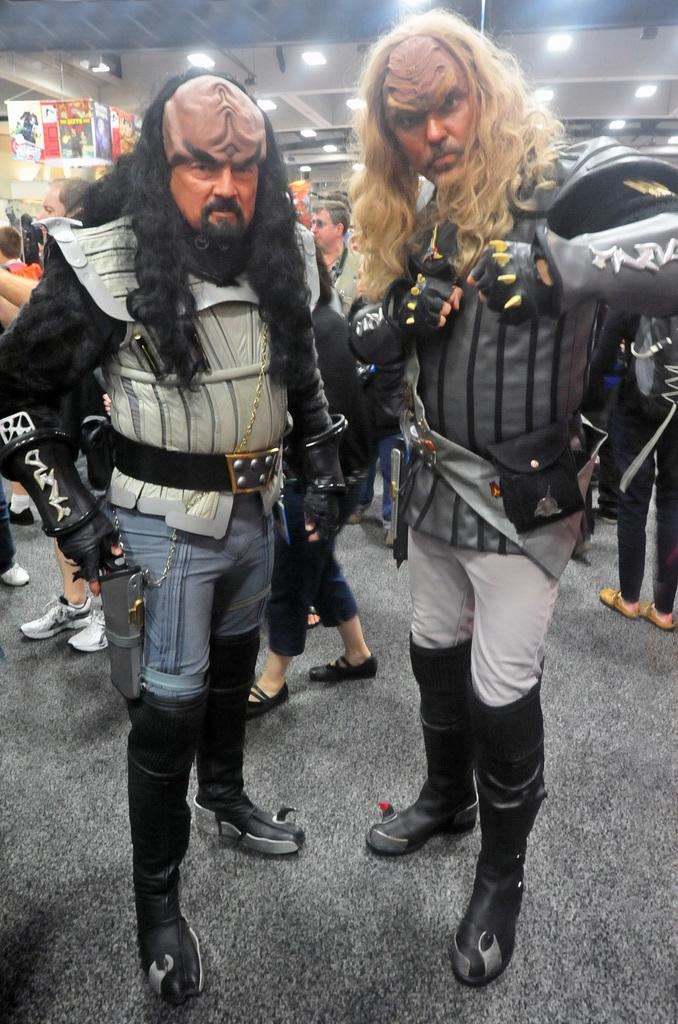How many people are in the image? There is a group of people in the image. What is the position of the people in the image? The people are standing on the ground. Can you describe the appearance of any specific individuals in the image? Two persons are wearing costumes. What can be seen in the background of the image? There are group of lights in the background of the image. What type of knowledge is being shared among the people in the image? There is no indication in the image of any knowledge being shared among the people. What type of machine is being used by the people in the image? There is no machine present in the image; the people are standing on the ground. 